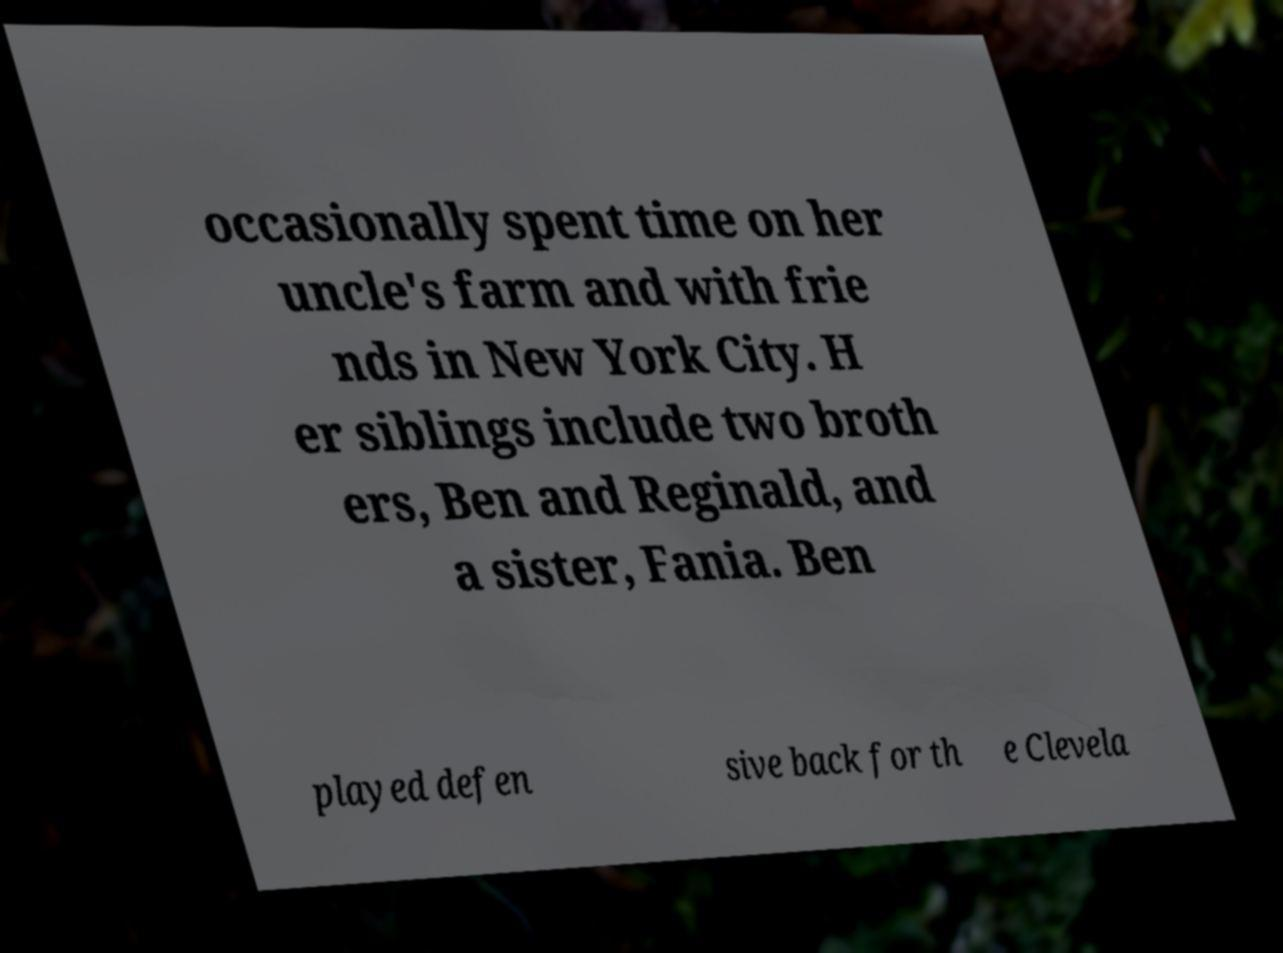I need the written content from this picture converted into text. Can you do that? occasionally spent time on her uncle's farm and with frie nds in New York City. H er siblings include two broth ers, Ben and Reginald, and a sister, Fania. Ben played defen sive back for th e Clevela 